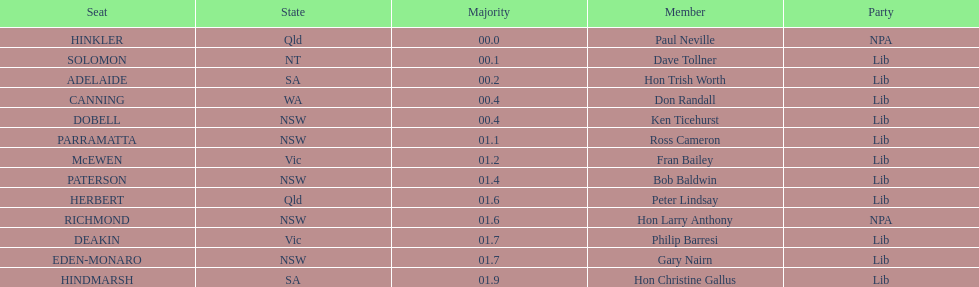What is the overall number of seats? 13. 